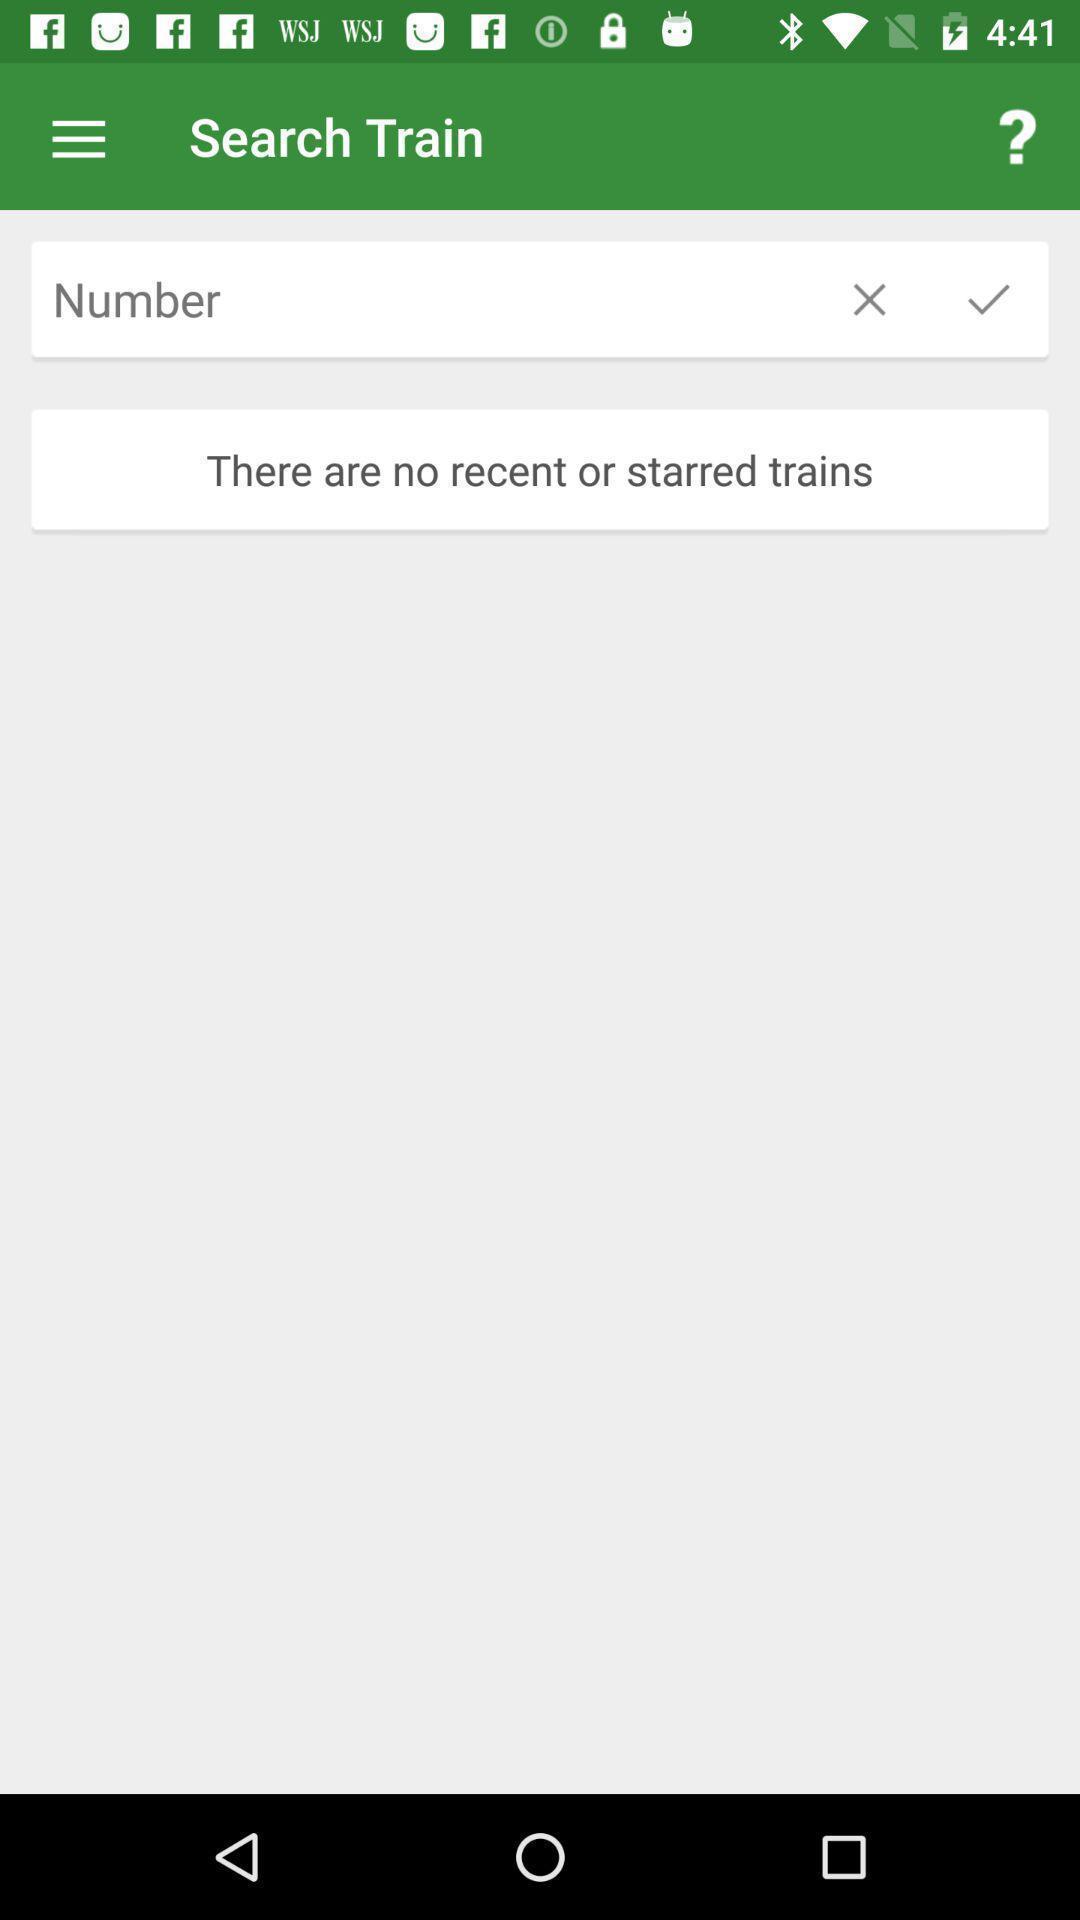Describe the content in this image. Search page displayed in an train application. 